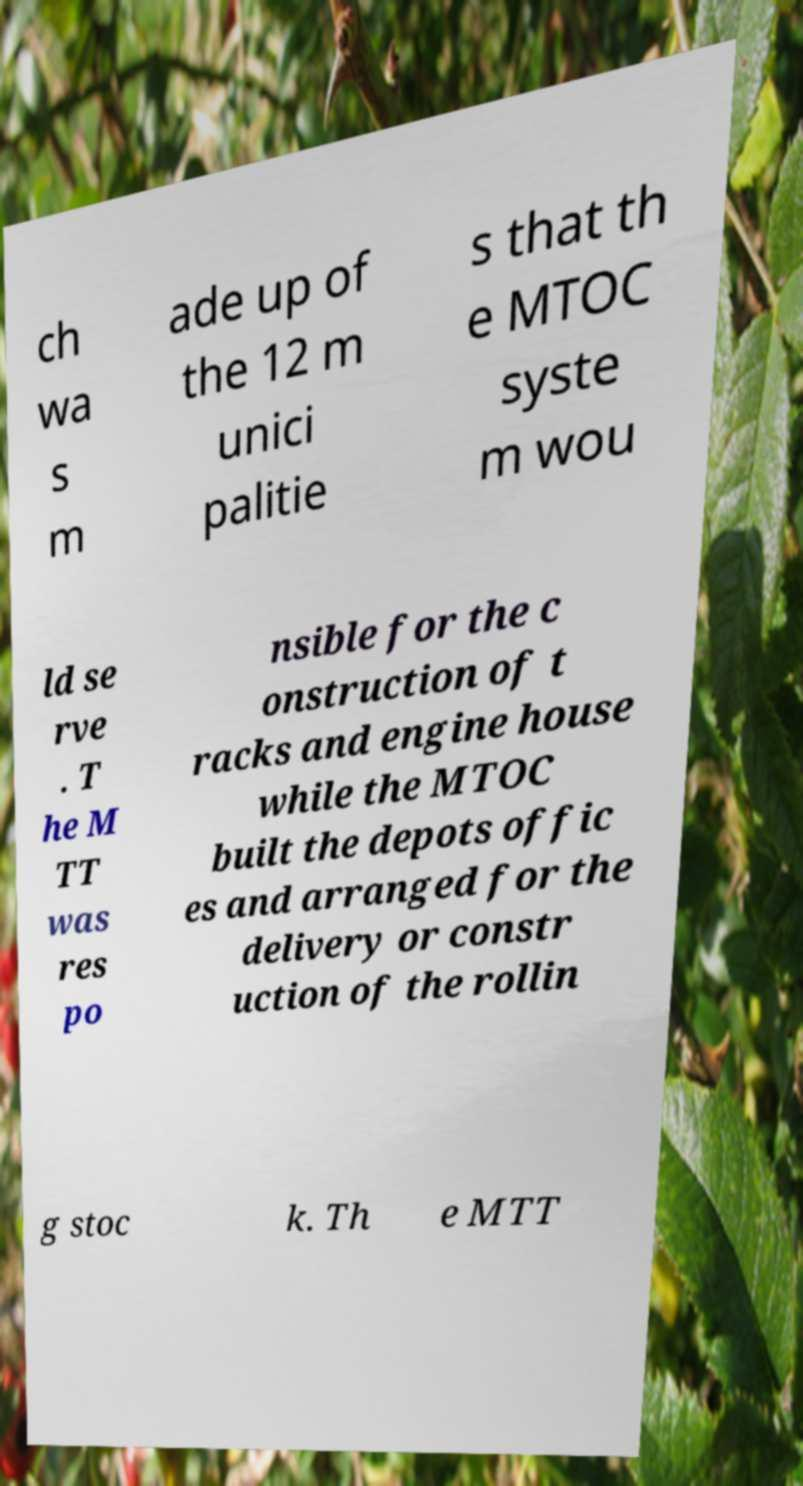Can you accurately transcribe the text from the provided image for me? ch wa s m ade up of the 12 m unici palitie s that th e MTOC syste m wou ld se rve . T he M TT was res po nsible for the c onstruction of t racks and engine house while the MTOC built the depots offic es and arranged for the delivery or constr uction of the rollin g stoc k. Th e MTT 